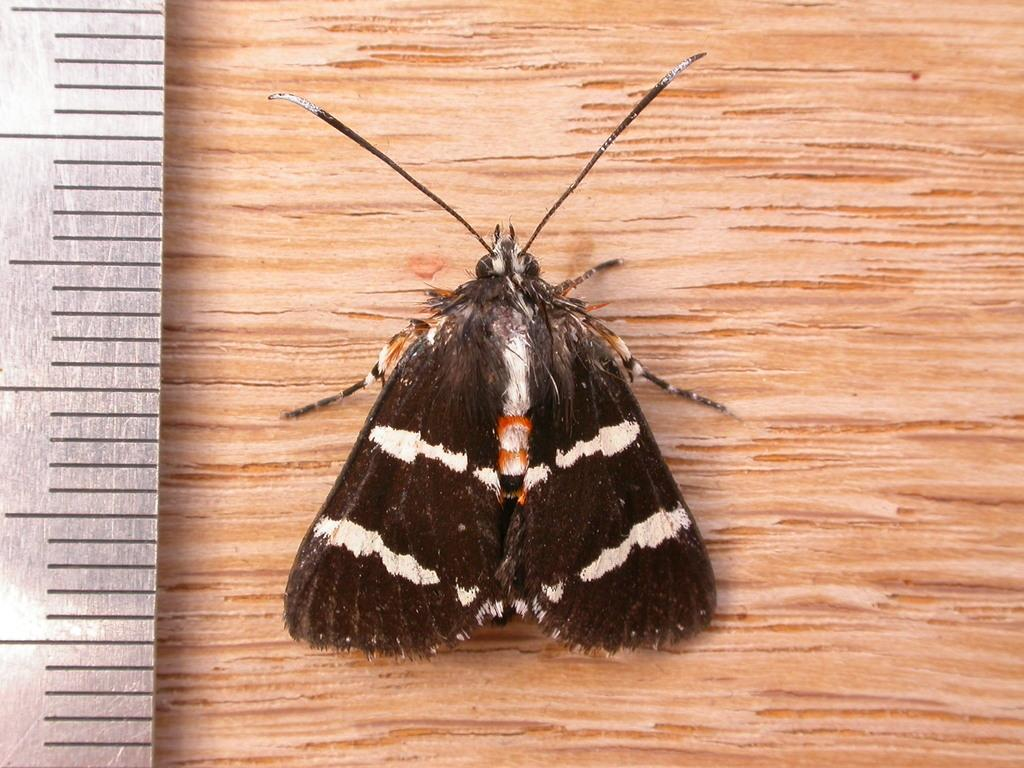What is the main subject in the middle of the image? There is a moth in the middle of the image. What object can be seen on the left side of the image? There is a steel measuring scale on the left side of the image. What type of surface is visible at the bottom of the image? There is a wooden surface at the bottom of the image. Can you tell me how many fairies are sitting on the moth in the image? There are no fairies present in the image; it features a moth and other objects. What substance is the moth made of in the image? The moth is a living creature and not made of any substance in the image. 